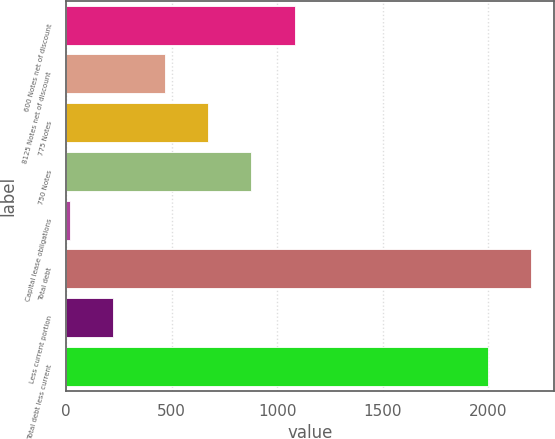<chart> <loc_0><loc_0><loc_500><loc_500><bar_chart><fcel>600 Notes net of discount<fcel>8125 Notes net of discount<fcel>775 Notes<fcel>750 Notes<fcel>Capital lease obligations<fcel>Total debt<fcel>Less current portion<fcel>Total debt less current<nl><fcel>1082.6<fcel>470<fcel>674.2<fcel>878.4<fcel>16<fcel>2202.2<fcel>220.2<fcel>1998<nl></chart> 